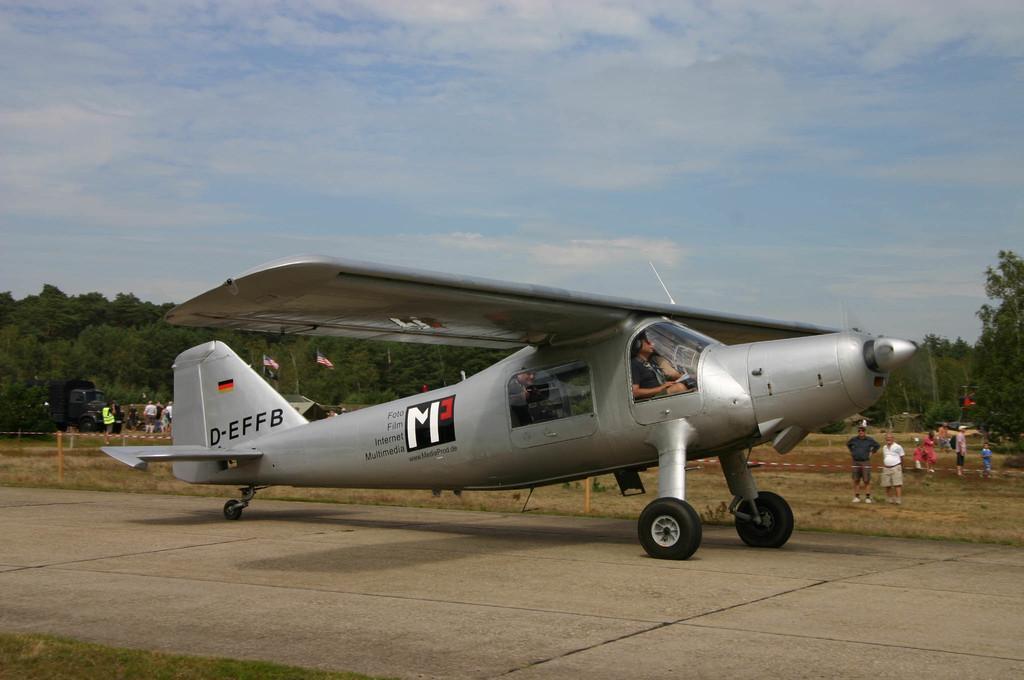Could you give a brief overview of what you see in this image? In this image, we can see people in the helicopter and in the background, there are flags, trees, poles, ribbons and there are people. At the top, there are clouds in the sky and at the bottom, there is a road. 